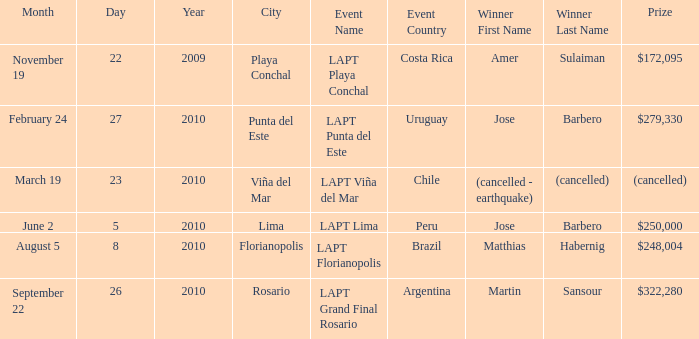Give me the full table as a dictionary. {'header': ['Month', 'Day', 'Year', 'City', 'Event Name', 'Event Country', 'Winner First Name', 'Winner Last Name', 'Prize'], 'rows': [['November 19', '22', '2009', 'Playa Conchal', 'LAPT Playa Conchal', 'Costa Rica', 'Amer', 'Sulaiman', '$172,095'], ['February 24', '27', '2010', 'Punta del Este', 'LAPT Punta del Este', 'Uruguay', 'Jose', 'Barbero', '$279,330'], ['March 19', '23', '2010', 'Viña del Mar', 'LAPT Viña del Mar', 'Chile', '(cancelled - earthquake)', '(cancelled)', '(cancelled)'], ['June 2', '5', '2010', 'Lima', 'LAPT Lima', 'Peru', 'Jose', 'Barbero', '$250,000'], ['August 5', '8', '2010', 'Florianopolis', 'LAPT Florianopolis', 'Brazil', 'Matthias', 'Habernig', '$248,004'], ['September 22', '26', '2010', 'Rosario', 'LAPT Grand Final Rosario', 'Argentina', 'Martin', 'Sansour', '$322,280']]} What event has a $248,004 prize? LAPT Florianopolis - Brazil. 